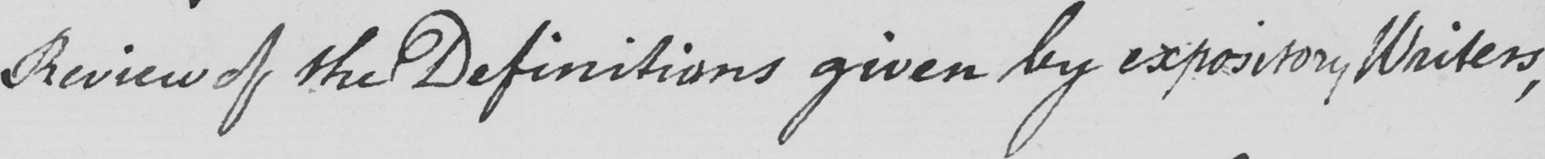What text is written in this handwritten line? review of the Definitions given by expository Writers , 